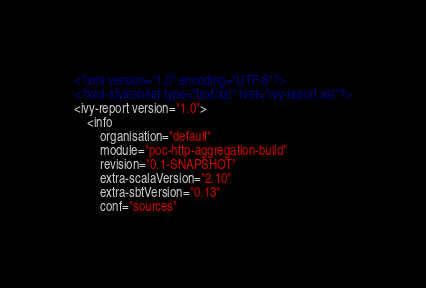<code> <loc_0><loc_0><loc_500><loc_500><_XML_><?xml version="1.0" encoding="UTF-8"?>
<?xml-stylesheet type="text/xsl" href="ivy-report.xsl"?>
<ivy-report version="1.0">
	<info
		organisation="default"
		module="poc-http-aggregation-build"
		revision="0.1-SNAPSHOT"
		extra-scalaVersion="2.10"
		extra-sbtVersion="0.13"
		conf="sources"</code> 